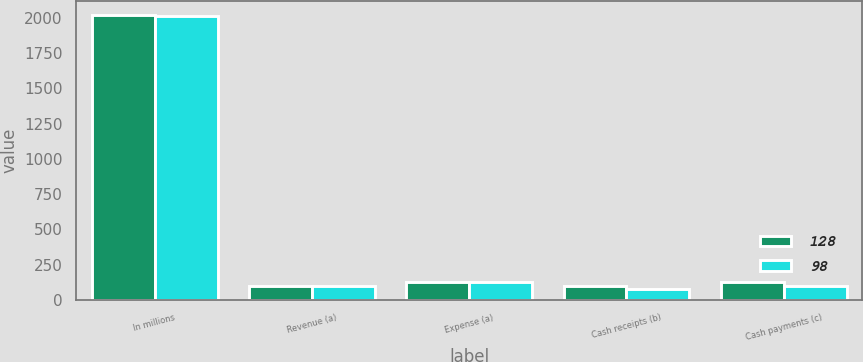Convert chart to OTSL. <chart><loc_0><loc_0><loc_500><loc_500><stacked_bar_chart><ecel><fcel>In millions<fcel>Revenue (a)<fcel>Expense (a)<fcel>Cash receipts (b)<fcel>Cash payments (c)<nl><fcel>128<fcel>2018<fcel>95<fcel>128<fcel>95<fcel>128<nl><fcel>98<fcel>2016<fcel>95<fcel>128<fcel>77<fcel>98<nl></chart> 